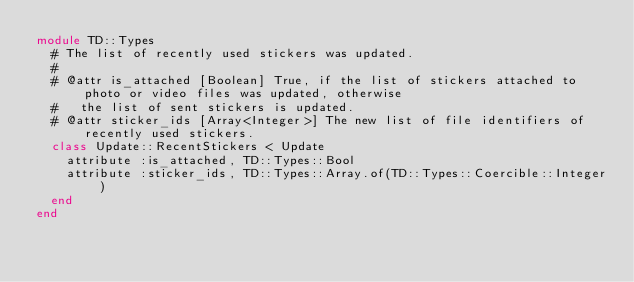Convert code to text. <code><loc_0><loc_0><loc_500><loc_500><_Ruby_>module TD::Types
  # The list of recently used stickers was updated.
  #
  # @attr is_attached [Boolean] True, if the list of stickers attached to photo or video files was updated, otherwise
  #   the list of sent stickers is updated.
  # @attr sticker_ids [Array<Integer>] The new list of file identifiers of recently used stickers.
  class Update::RecentStickers < Update
    attribute :is_attached, TD::Types::Bool
    attribute :sticker_ids, TD::Types::Array.of(TD::Types::Coercible::Integer)
  end
end
</code> 